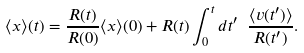Convert formula to latex. <formula><loc_0><loc_0><loc_500><loc_500>\langle x \rangle ( t ) = \frac { R ( t ) } { R ( 0 ) } \langle x \rangle ( 0 ) + R ( t ) \int _ { 0 } ^ { t } d t ^ { \prime } \ \frac { \langle v ( t ^ { \prime } ) \rangle } { R ( t ^ { \prime } ) } .</formula> 